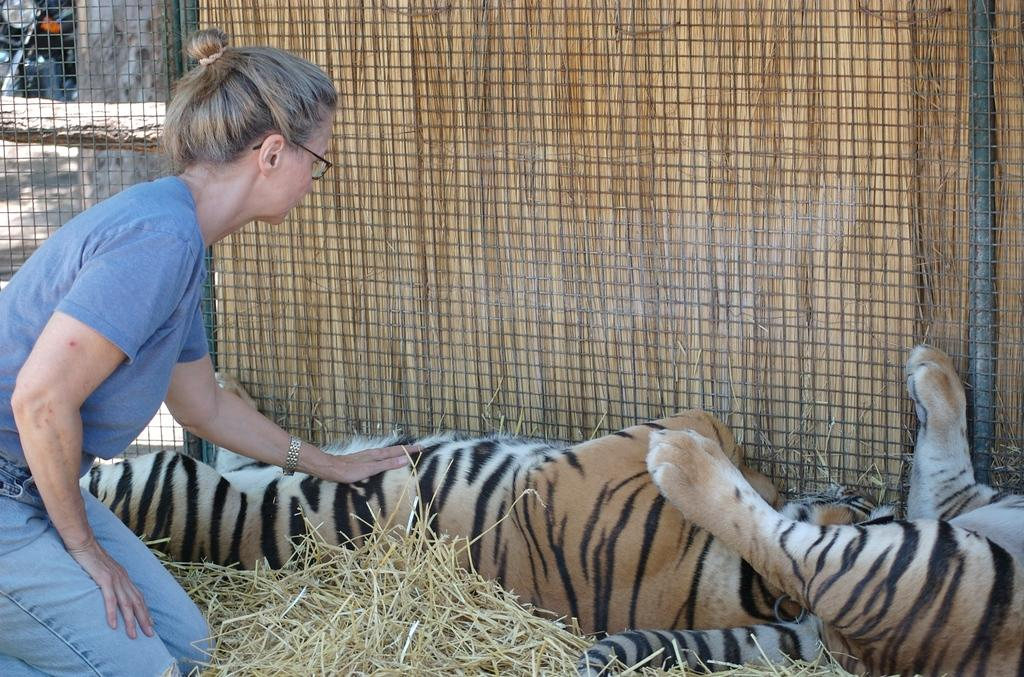Who is present in the image? There is a lady in the image. What other living beings can be seen in the image? There are animals in the image. What type of vegetation is visible in the image? Dried grass is visible in the image. What type of barrier is present in the image? There is a fence in the image. What material is present in the image? Wood is present in the image. What is visible beneath the lady and animals? The ground is visible in the image. What mode of transportation is present in the image? There is a vehicle in the image. What type of credit card is the lady using in the image? There is no credit card present in the image. Does the lady have a brother in the image? The provided facts do not mention the presence of a brother in the image. 